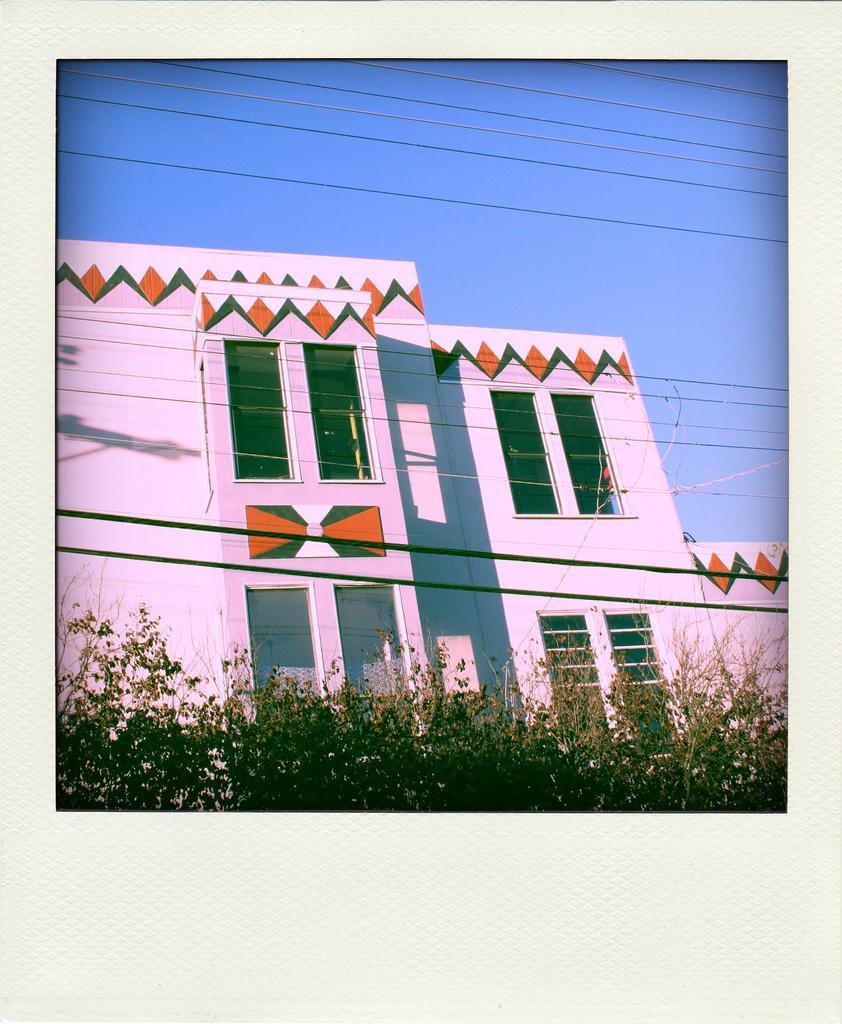Could you give a brief overview of what you see in this image? In this image I can see a photograph on the cream colored surface in which I can see few trees, few wires and a building which is orange, green and pink in color. I can see few windows of the building and the sky in the background. 